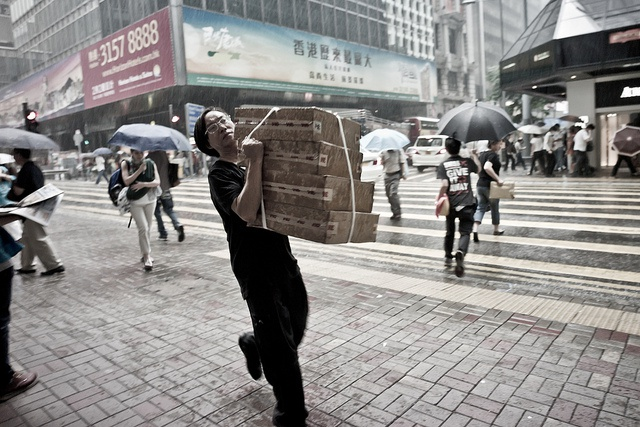Describe the objects in this image and their specific colors. I can see people in darkgray, black, gray, and lightgray tones, people in darkgray, gray, lightgray, and black tones, people in darkgray, black, gray, and lightgray tones, people in darkgray, black, gray, and lightgray tones, and people in darkgray, black, gray, and lightgray tones in this image. 